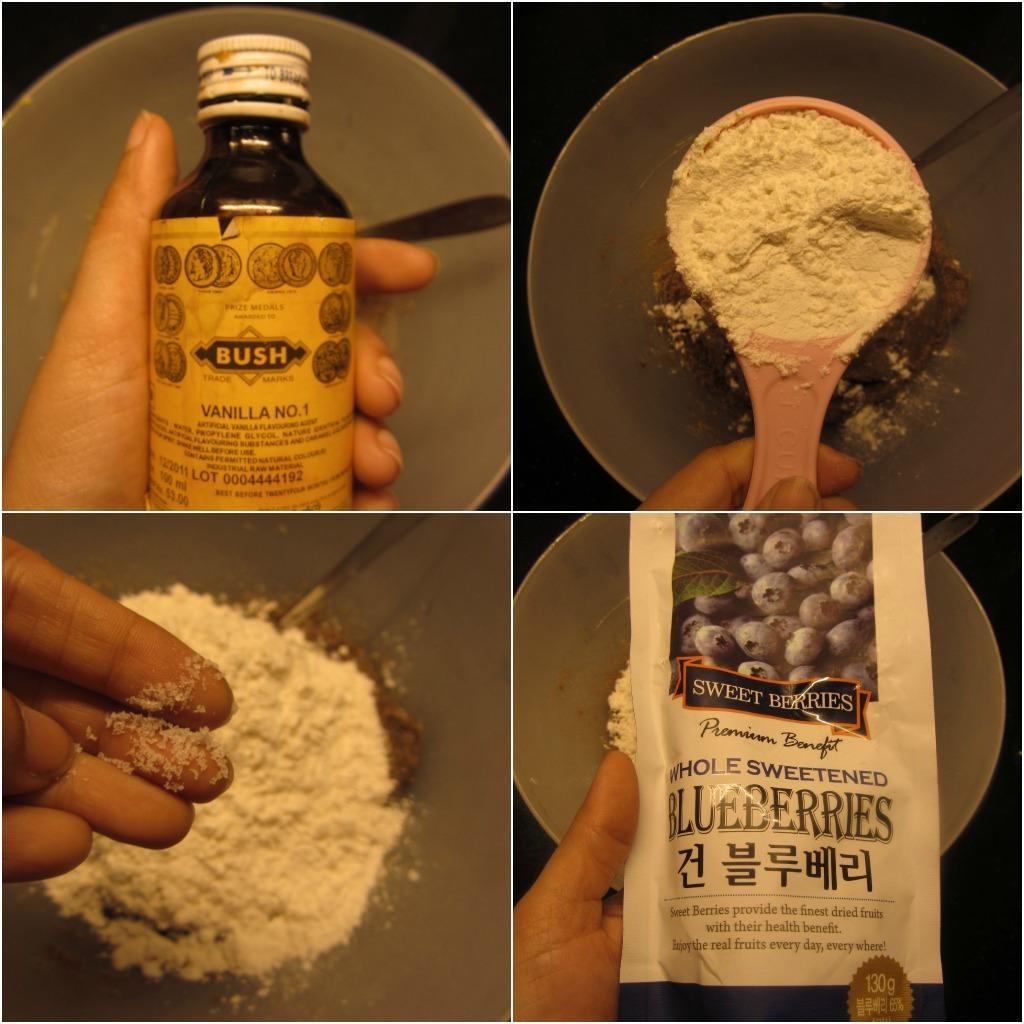Can you describe this image briefly? This picture is collage of four images. In the first picture, a hand is holding a bottle, below that there is a bowl and a spoon. In the second image there is a bowl and a spoonful of flour. In the third picture, there is a hand and a flour. In the fourth picture, a hand is holding a packet below that there is a bowl. 